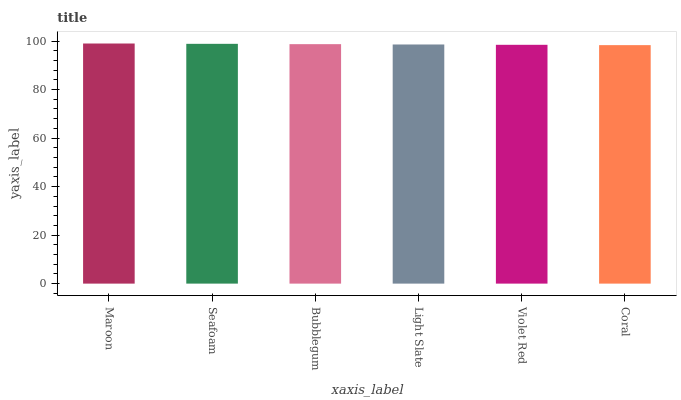Is Coral the minimum?
Answer yes or no. Yes. Is Maroon the maximum?
Answer yes or no. Yes. Is Seafoam the minimum?
Answer yes or no. No. Is Seafoam the maximum?
Answer yes or no. No. Is Maroon greater than Seafoam?
Answer yes or no. Yes. Is Seafoam less than Maroon?
Answer yes or no. Yes. Is Seafoam greater than Maroon?
Answer yes or no. No. Is Maroon less than Seafoam?
Answer yes or no. No. Is Bubblegum the high median?
Answer yes or no. Yes. Is Light Slate the low median?
Answer yes or no. Yes. Is Light Slate the high median?
Answer yes or no. No. Is Seafoam the low median?
Answer yes or no. No. 